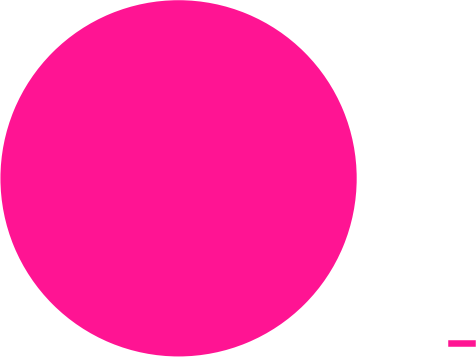Convert chart to OTSL. <chart><loc_0><loc_0><loc_500><loc_500><pie_chart><ecel><nl><fcel>100.0%<nl></chart> 